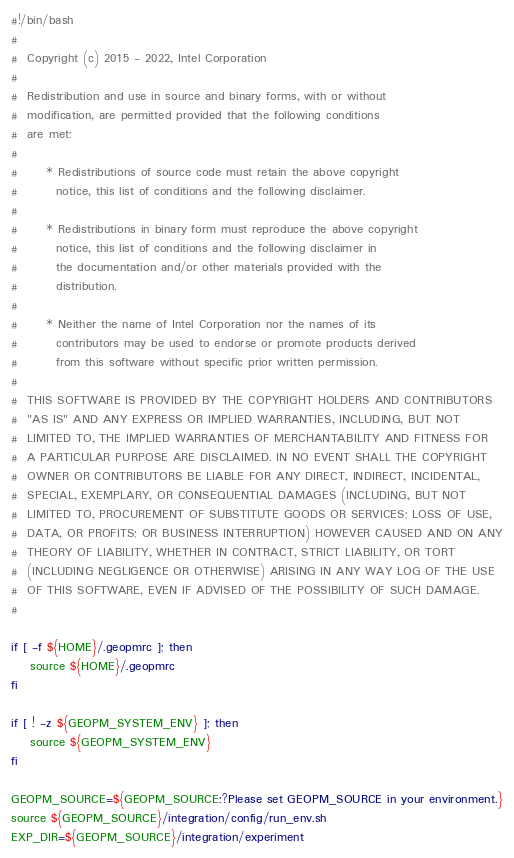<code> <loc_0><loc_0><loc_500><loc_500><_Bash_>#!/bin/bash
#
#  Copyright (c) 2015 - 2022, Intel Corporation
#
#  Redistribution and use in source and binary forms, with or without
#  modification, are permitted provided that the following conditions
#  are met:
#
#      * Redistributions of source code must retain the above copyright
#        notice, this list of conditions and the following disclaimer.
#
#      * Redistributions in binary form must reproduce the above copyright
#        notice, this list of conditions and the following disclaimer in
#        the documentation and/or other materials provided with the
#        distribution.
#
#      * Neither the name of Intel Corporation nor the names of its
#        contributors may be used to endorse or promote products derived
#        from this software without specific prior written permission.
#
#  THIS SOFTWARE IS PROVIDED BY THE COPYRIGHT HOLDERS AND CONTRIBUTORS
#  "AS IS" AND ANY EXPRESS OR IMPLIED WARRANTIES, INCLUDING, BUT NOT
#  LIMITED TO, THE IMPLIED WARRANTIES OF MERCHANTABILITY AND FITNESS FOR
#  A PARTICULAR PURPOSE ARE DISCLAIMED. IN NO EVENT SHALL THE COPYRIGHT
#  OWNER OR CONTRIBUTORS BE LIABLE FOR ANY DIRECT, INDIRECT, INCIDENTAL,
#  SPECIAL, EXEMPLARY, OR CONSEQUENTIAL DAMAGES (INCLUDING, BUT NOT
#  LIMITED TO, PROCUREMENT OF SUBSTITUTE GOODS OR SERVICES; LOSS OF USE,
#  DATA, OR PROFITS; OR BUSINESS INTERRUPTION) HOWEVER CAUSED AND ON ANY
#  THEORY OF LIABILITY, WHETHER IN CONTRACT, STRICT LIABILITY, OR TORT
#  (INCLUDING NEGLIGENCE OR OTHERWISE) ARISING IN ANY WAY LOG OF THE USE
#  OF THIS SOFTWARE, EVEN IF ADVISED OF THE POSSIBILITY OF SUCH DAMAGE.
#

if [ -f ${HOME}/.geopmrc ]; then
    source ${HOME}/.geopmrc
fi

if [ ! -z ${GEOPM_SYSTEM_ENV} ]; then
    source ${GEOPM_SYSTEM_ENV}
fi

GEOPM_SOURCE=${GEOPM_SOURCE:?Please set GEOPM_SOURCE in your environment.}
source ${GEOPM_SOURCE}/integration/config/run_env.sh
EXP_DIR=${GEOPM_SOURCE}/integration/experiment
</code> 